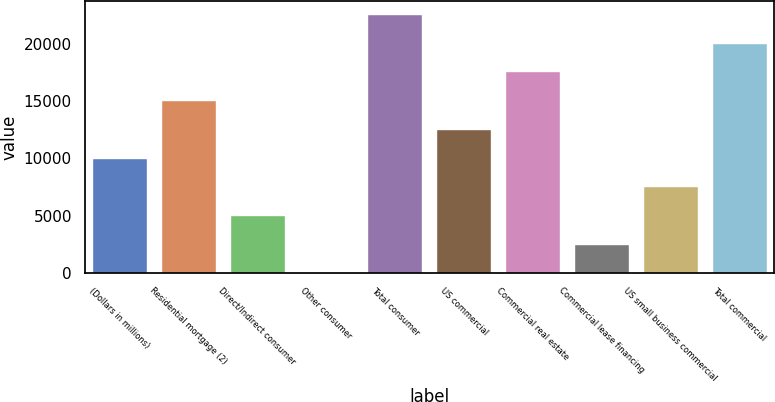<chart> <loc_0><loc_0><loc_500><loc_500><bar_chart><fcel>(Dollars in millions)<fcel>Residential mortgage (2)<fcel>Direct/Indirect consumer<fcel>Other consumer<fcel>Total consumer<fcel>US commercial<fcel>Commercial real estate<fcel>Commercial lease financing<fcel>US small business commercial<fcel>Total commercial<nl><fcel>10051<fcel>15069<fcel>5033<fcel>15<fcel>22596<fcel>12560<fcel>17578<fcel>2524<fcel>7542<fcel>20087<nl></chart> 